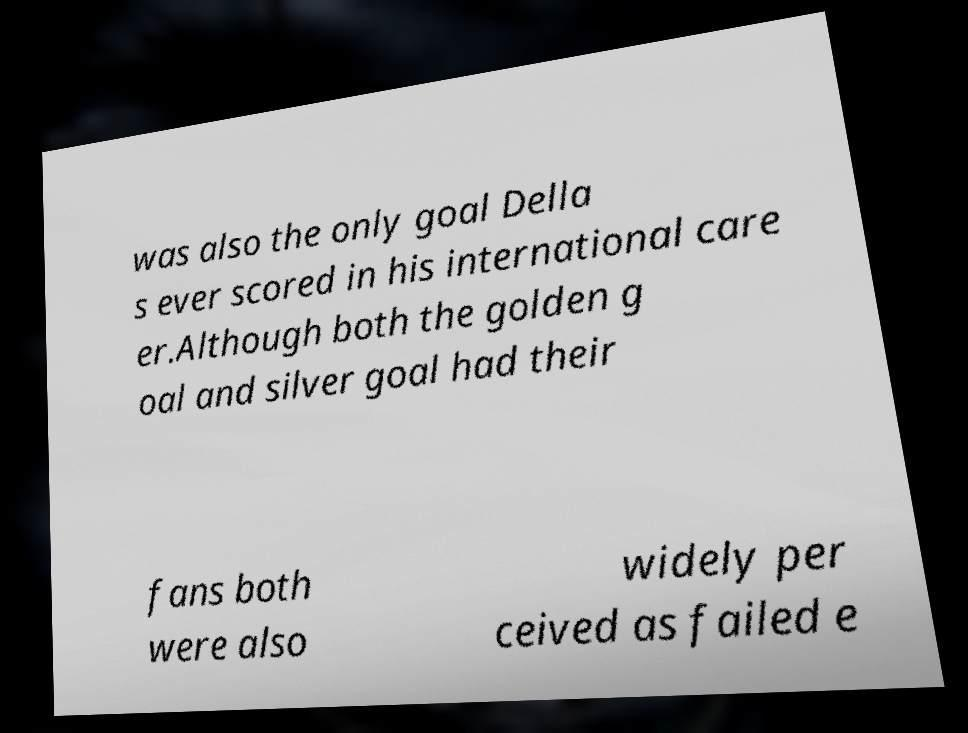I need the written content from this picture converted into text. Can you do that? was also the only goal Della s ever scored in his international care er.Although both the golden g oal and silver goal had their fans both were also widely per ceived as failed e 